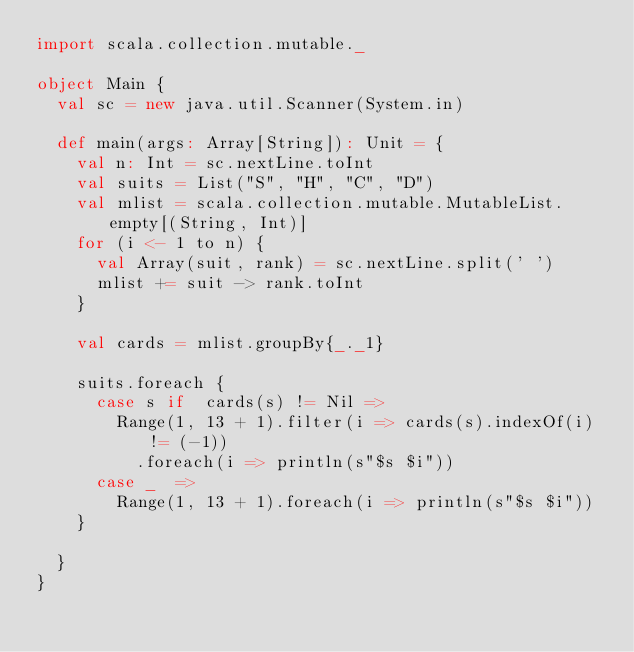<code> <loc_0><loc_0><loc_500><loc_500><_Scala_>import scala.collection.mutable._

object Main {
  val sc = new java.util.Scanner(System.in)

  def main(args: Array[String]): Unit = {
    val n: Int = sc.nextLine.toInt
    val suits = List("S", "H", "C", "D")
    val mlist = scala.collection.mutable.MutableList.empty[(String, Int)]
    for (i <- 1 to n) {
      val Array(suit, rank) = sc.nextLine.split(' ')
      mlist += suit -> rank.toInt
    }

    val cards = mlist.groupBy{_._1}

    suits.foreach {
      case s if  cards(s) != Nil =>
        Range(1, 13 + 1).filter(i => cards(s).indexOf(i) != (-1))
          .foreach(i => println(s"$s $i"))
      case _  =>
        Range(1, 13 + 1).foreach(i => println(s"$s $i"))
    }

  }
}</code> 